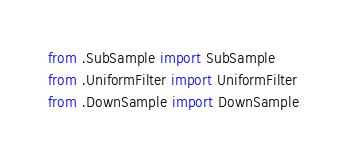Convert code to text. <code><loc_0><loc_0><loc_500><loc_500><_Python_>from .SubSample import SubSample
from .UniformFilter import UniformFilter
from .DownSample import DownSample
</code> 